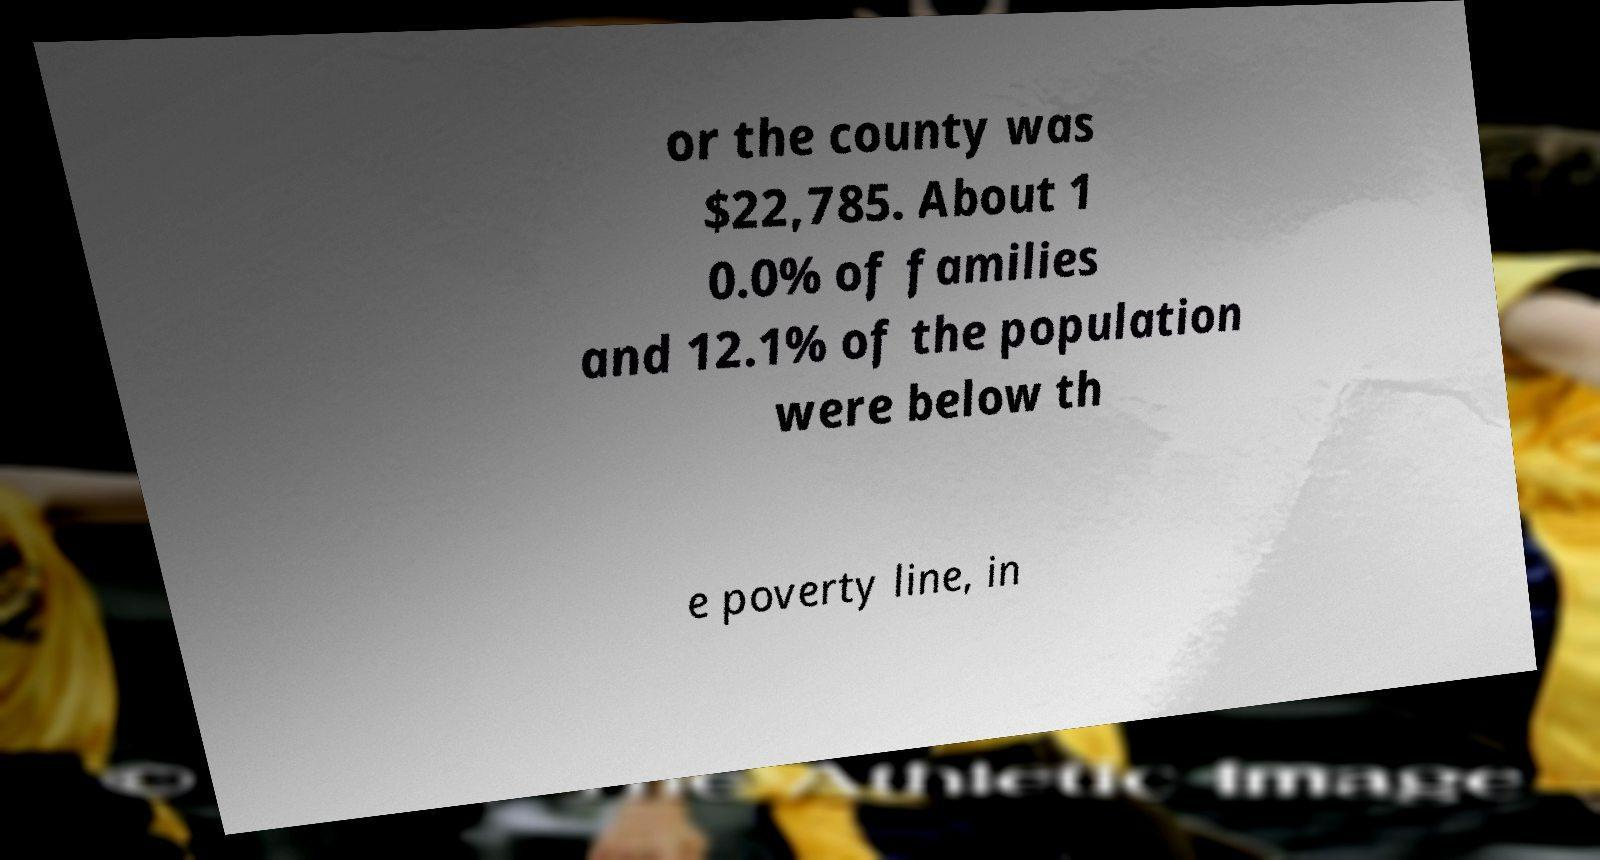Please read and relay the text visible in this image. What does it say? or the county was $22,785. About 1 0.0% of families and 12.1% of the population were below th e poverty line, in 